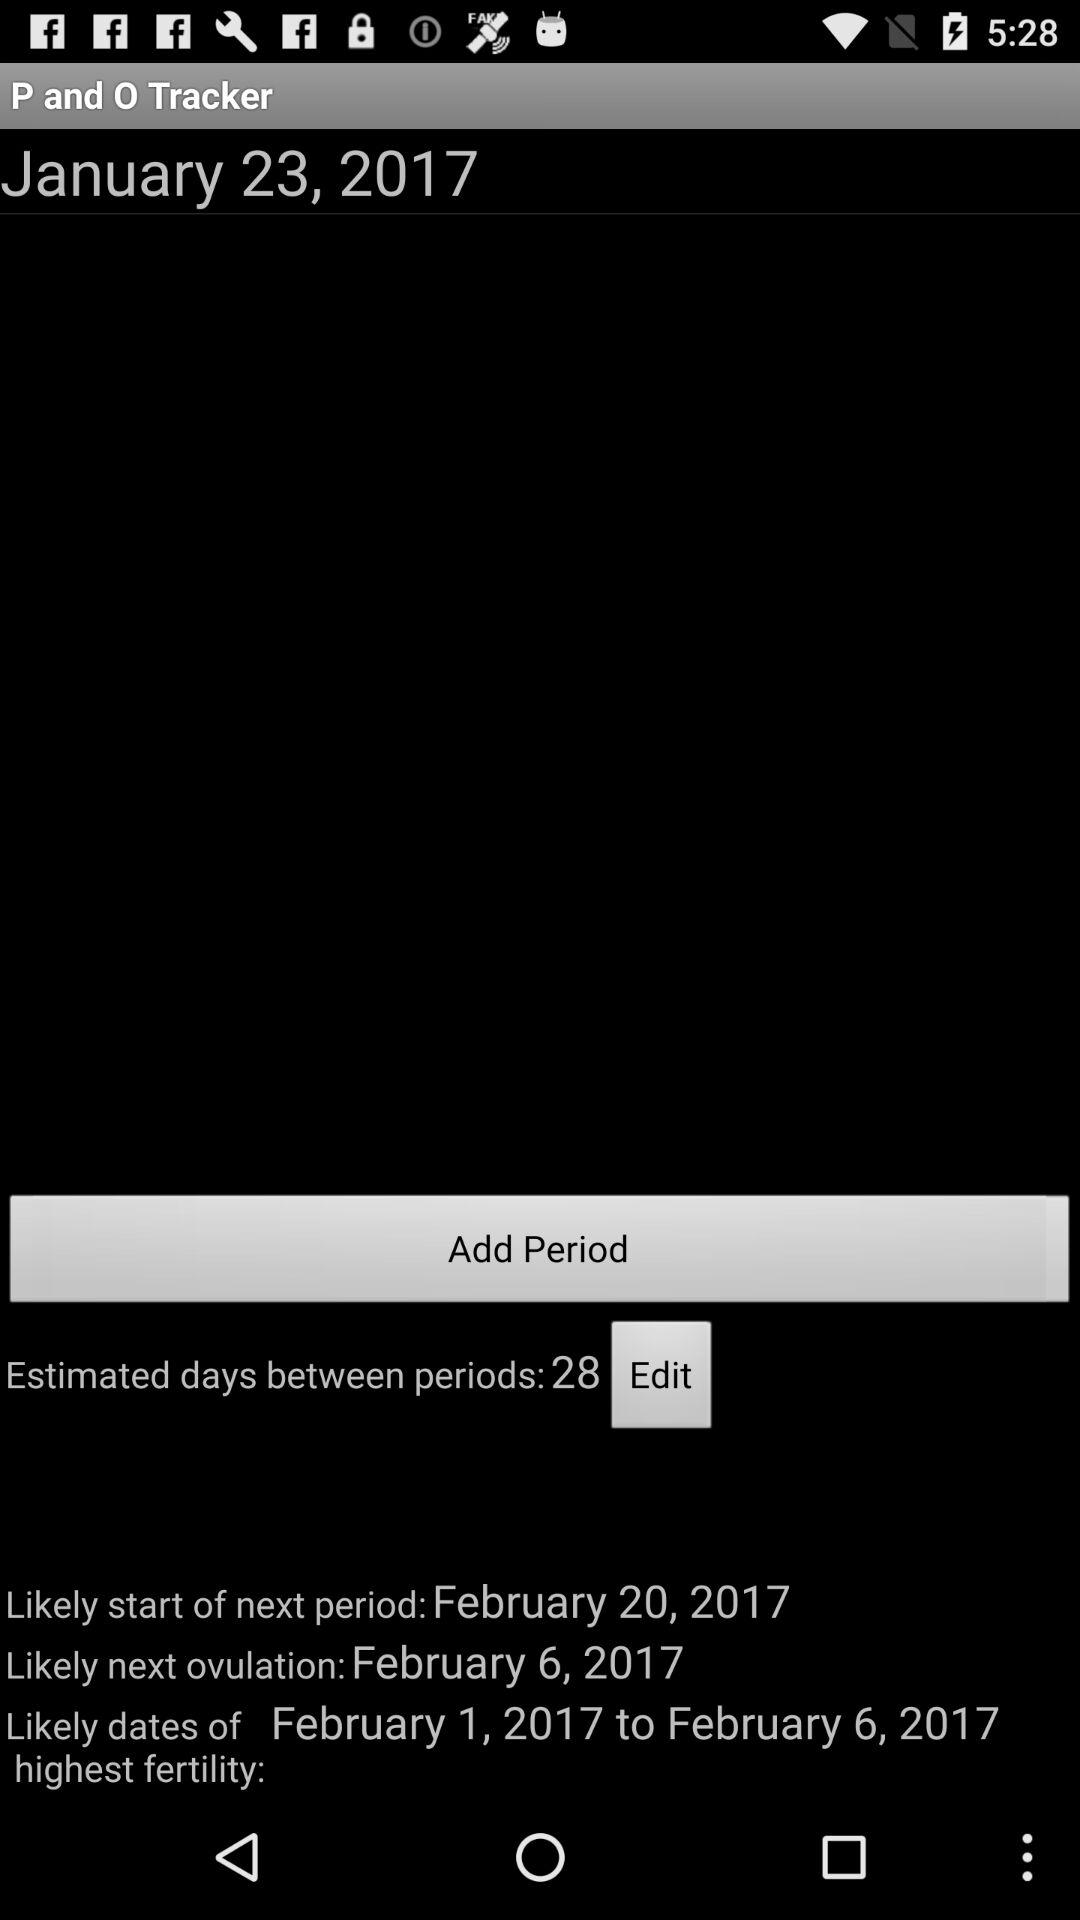What is the most likely start date for the next ovulation? The most likely start date for the next ovulation is February 6, 2017. 